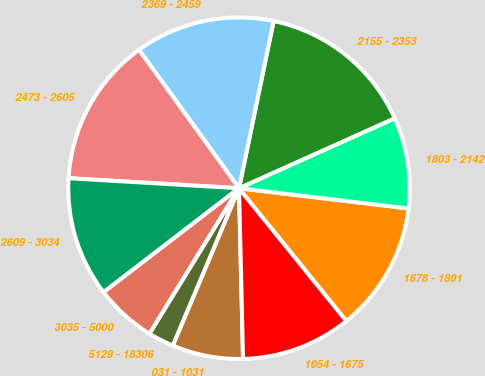Convert chart. <chart><loc_0><loc_0><loc_500><loc_500><pie_chart><fcel>031 - 1031<fcel>1054 - 1675<fcel>1678 - 1801<fcel>1803 - 2142<fcel>2155 - 2353<fcel>2369 - 2459<fcel>2473 - 2605<fcel>2609 - 3034<fcel>3035 - 5000<fcel>5129 - 18306<nl><fcel>6.72%<fcel>10.45%<fcel>12.28%<fcel>8.61%<fcel>15.03%<fcel>13.2%<fcel>14.11%<fcel>11.36%<fcel>5.8%<fcel>2.43%<nl></chart> 